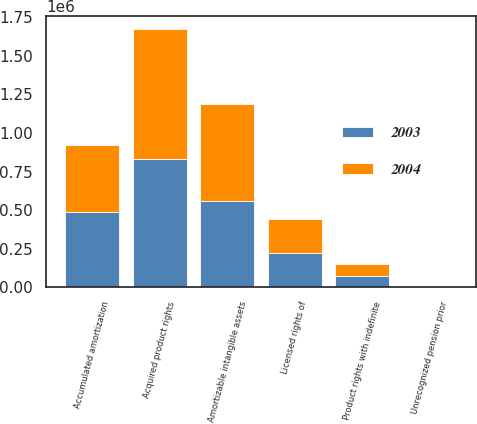Convert chart. <chart><loc_0><loc_0><loc_500><loc_500><stacked_bar_chart><ecel><fcel>Acquired product rights<fcel>Licensed rights of<fcel>Accumulated amortization<fcel>Amortizable intangible assets<fcel>Product rights with indefinite<fcel>Unrecognized pension prior<nl><fcel>2003<fcel>828186<fcel>219071<fcel>489238<fcel>558019<fcel>75738<fcel>4172<nl><fcel>2004<fcel>844141<fcel>221040<fcel>435014<fcel>630167<fcel>75738<fcel>4734<nl></chart> 